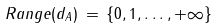Convert formula to latex. <formula><loc_0><loc_0><loc_500><loc_500>R a n g e ( d _ { A } ) \, = \, \{ 0 , 1 , \dots , + \infty \}</formula> 